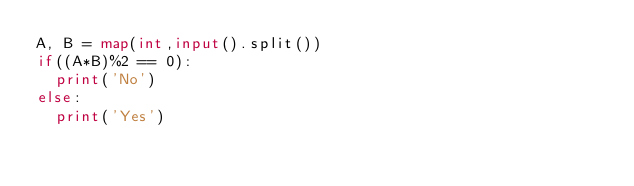<code> <loc_0><loc_0><loc_500><loc_500><_Python_>A, B = map(int,input().split())
if((A*B)%2 == 0):
  print('No')
else:
  print('Yes')</code> 